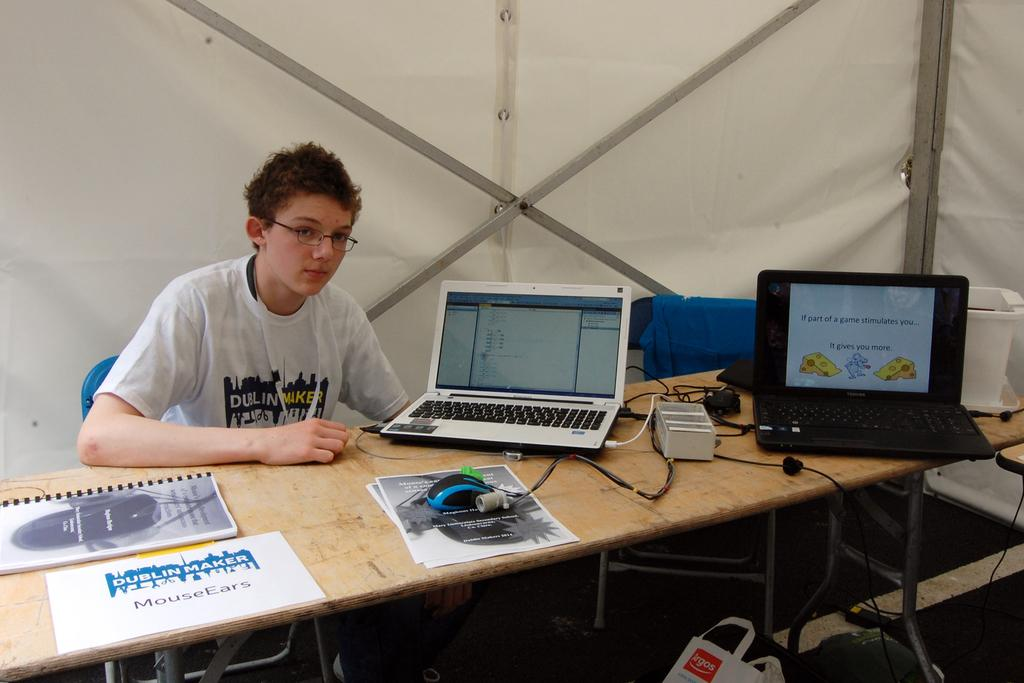<image>
Provide a brief description of the given image. a boy sitting at a table with two laptops, one displaying "if part of the game stimulates you it gives you more" 